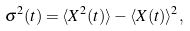Convert formula to latex. <formula><loc_0><loc_0><loc_500><loc_500>\sigma ^ { 2 } ( t ) = \langle X ^ { 2 } ( t ) \rangle - \langle X ( t ) \rangle ^ { 2 } ,</formula> 